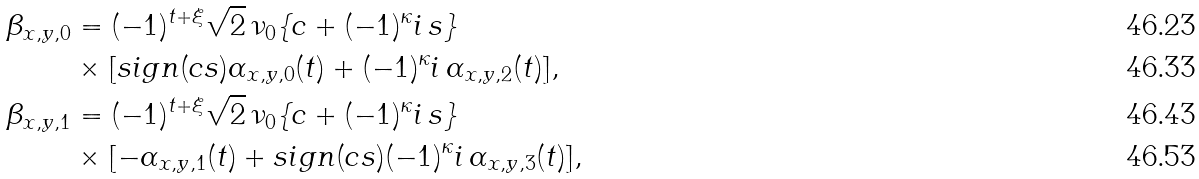<formula> <loc_0><loc_0><loc_500><loc_500>\beta _ { x , y , 0 } & = ( - 1 ) ^ { t + \xi } \sqrt { 2 } \, \nu _ { 0 } \{ c + ( - 1 ) ^ { \kappa } i \, s \} \\ & \times [ s i g n ( c s ) \alpha _ { x , y , 0 } ( t ) + ( - 1 ) ^ { \kappa } i \, \alpha _ { x , y , 2 } ( t ) ] , \\ \beta _ { x , y , 1 } & = ( - 1 ) ^ { t + \xi } \sqrt { 2 } \, \nu _ { 0 } \{ c + ( - 1 ) ^ { \kappa } i \, s \} \\ & \times [ - \alpha _ { x , y , 1 } ( t ) + s i g n ( c s ) ( - 1 ) ^ { \kappa } i \, \alpha _ { x , y , 3 } ( t ) ] ,</formula> 